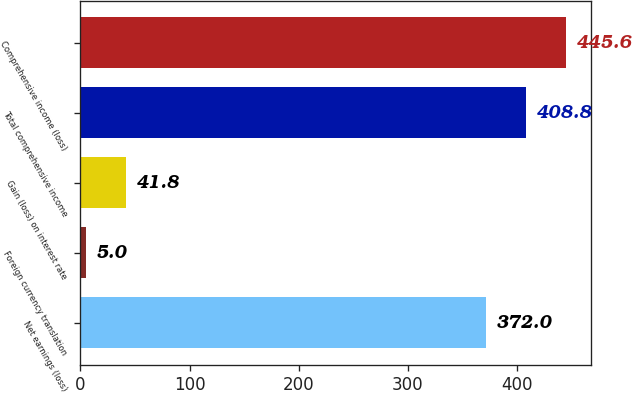<chart> <loc_0><loc_0><loc_500><loc_500><bar_chart><fcel>Net earnings (loss)<fcel>Foreign currency translation<fcel>Gain (loss) on interest rate<fcel>Total comprehensive income<fcel>Comprehensive income (loss)<nl><fcel>372<fcel>5<fcel>41.8<fcel>408.8<fcel>445.6<nl></chart> 